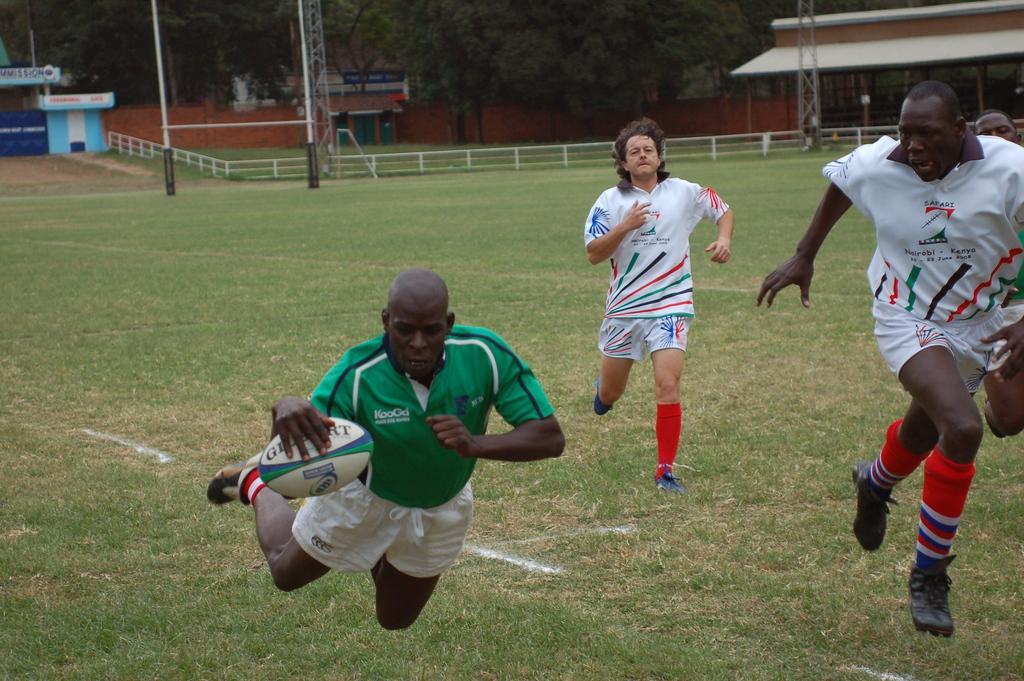Please provide a concise description of this image. In front of the image there is a person holding a rugby ball is in the air, behind the person there are a few other people running, behind them there is a goal post, metal rod fence and poles, trees and buildings with glass doors and walls. 